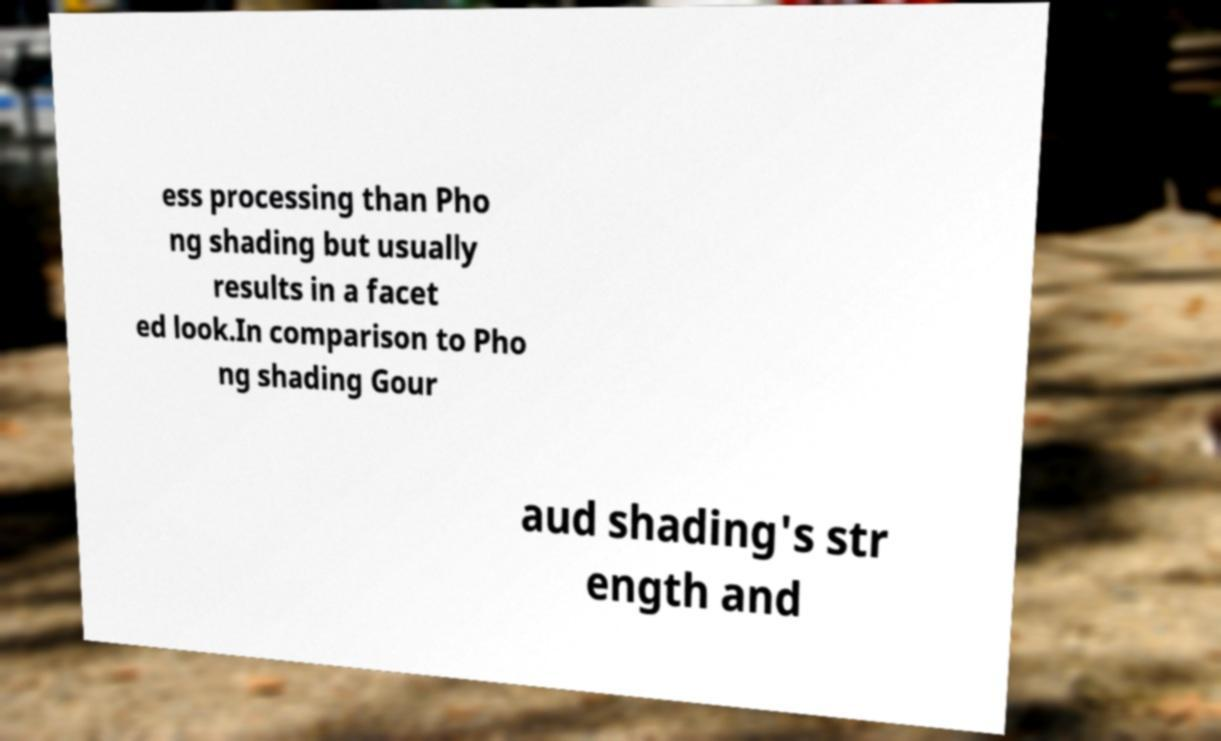Please read and relay the text visible in this image. What does it say? ess processing than Pho ng shading but usually results in a facet ed look.In comparison to Pho ng shading Gour aud shading's str ength and 